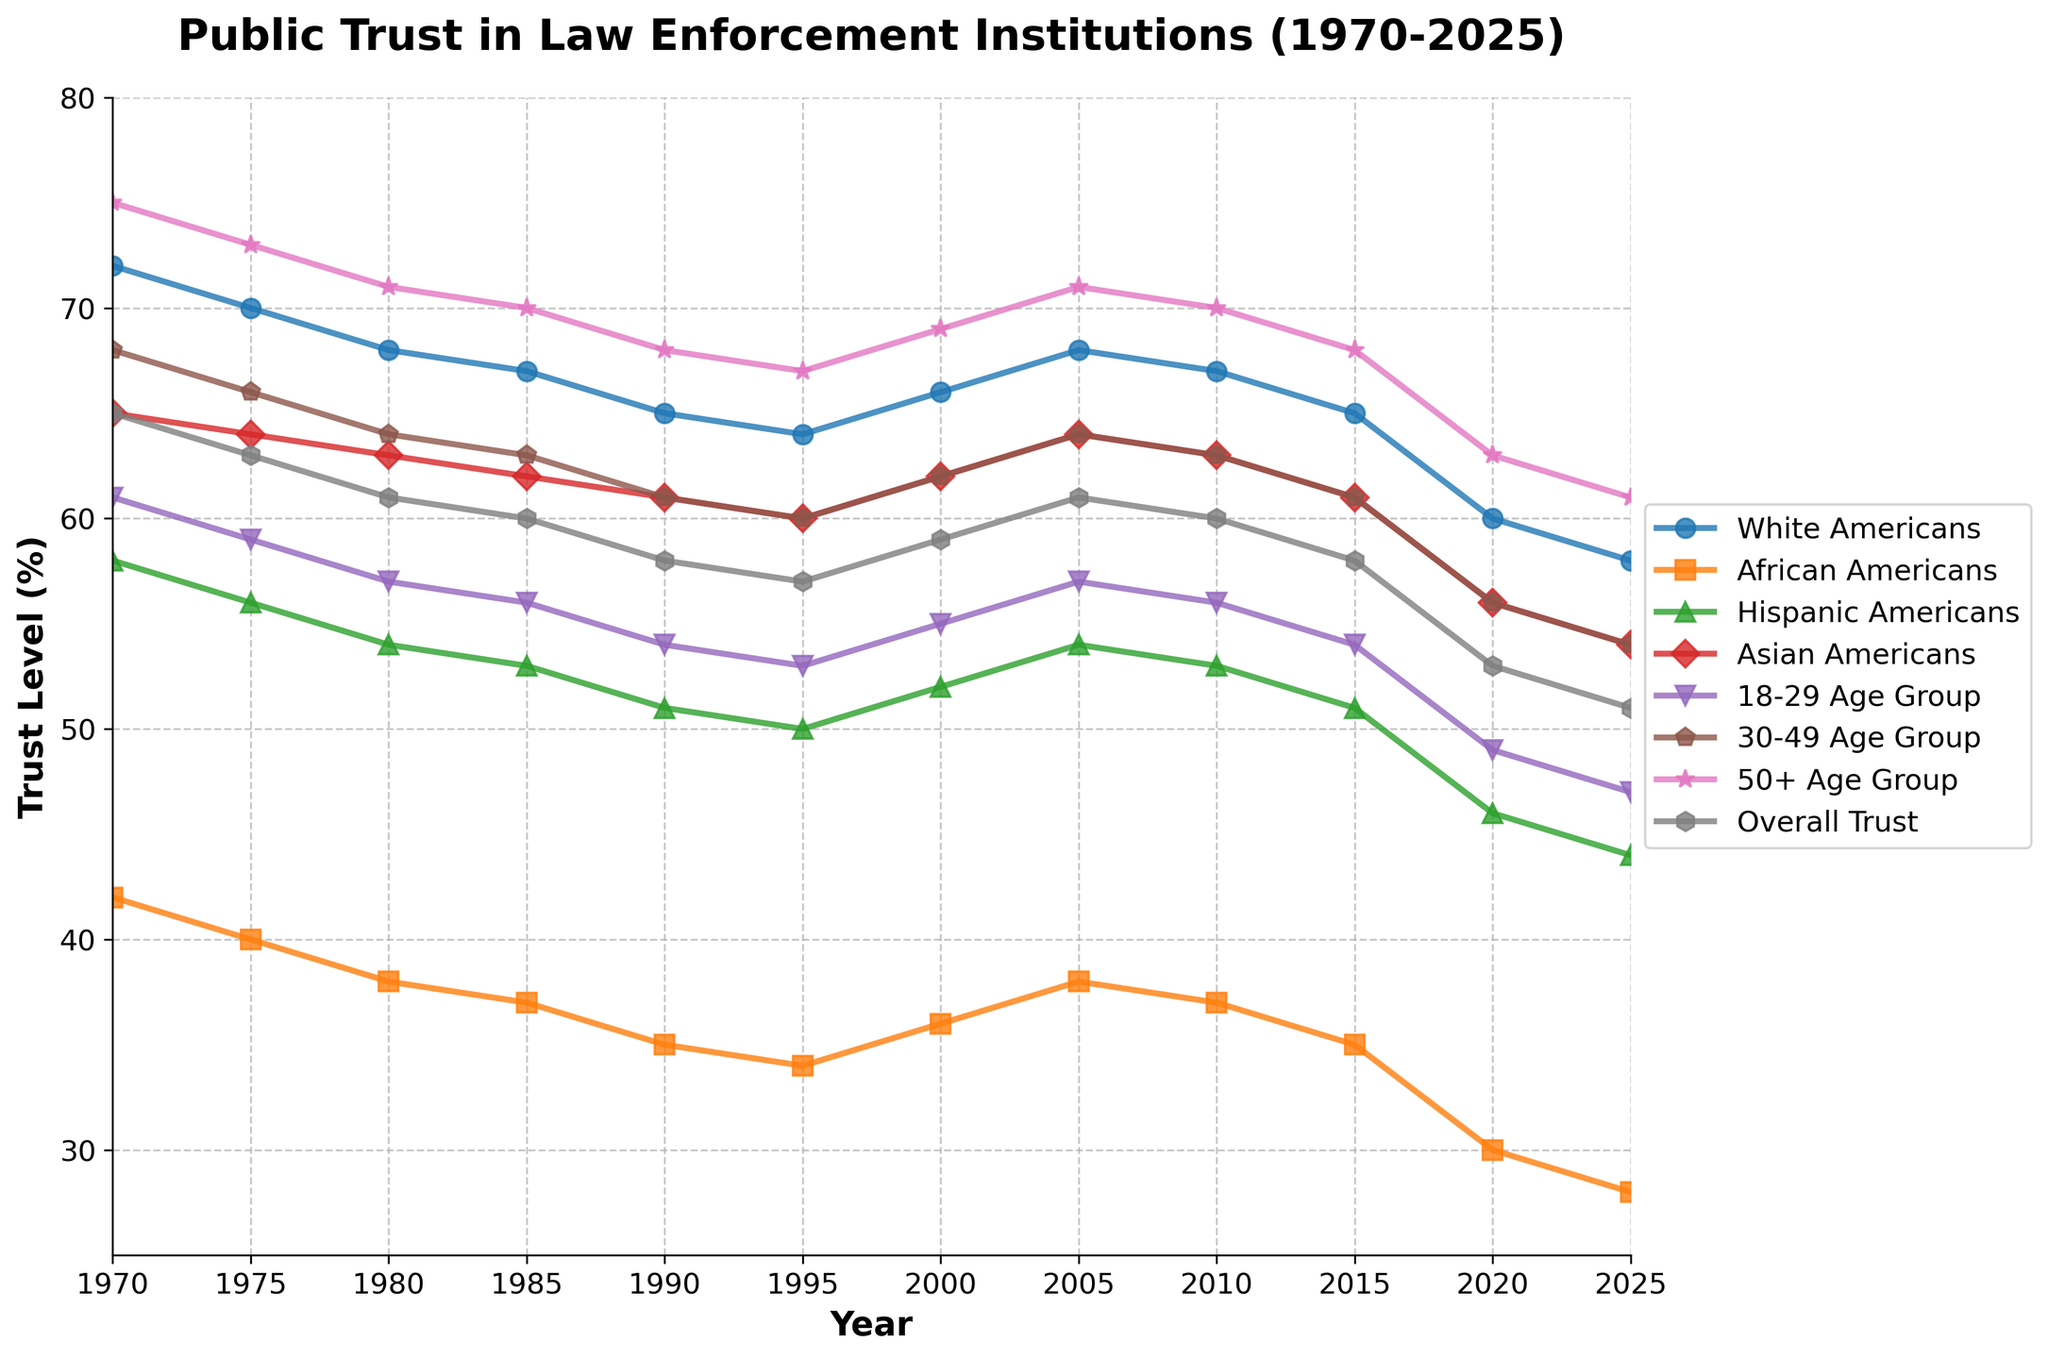What is the overall trend in public trust in law enforcement institutions from 1970 to 2025 for the 'Overall Trust' category? To determine the overall trend, look at the 'Overall Trust' line from 1970 to 2025. The trust level started at 65% in 1970 and gradually declined to 51% in 2025. Hence, the trend shows a decline in trust over time.
Answer: Overall trust has declined In which year did African Americans' trust in law enforcement drop below 30% for the first time? Trace the 'African Americans' line and identify the point where it first falls below 30%. In the figure, African Americans' trust level drops below 30% in the year 2020.
Answer: 2020 In 2025, which age group has the highest level of trust in law enforcement institutions? Examine the points for the year 2025 and compare the trust levels across the '18-29 Age Group', '30-49 Age Group', and '50+ Age Group'. The '50+ Age Group' has a trust level of 61%, which is higher than the other groups.
Answer: 50+ Age Group How does the trust level of Hispanic Americans in 1990 compare to the trust level of White Americans in the same year? Compare the two respective points in 1990. Hispanic Americans have a trust level of 51%, while White Americans have a trust level of 65%.
Answer: Lower by 14% What is the average trust level in law enforcement institutions for the 30-49 Age Group from 1970 to 2025? Calculate the average of the values for the '30-49 Age Group' from 1970 to 2025: (68+66+64+63+61+60+62+64+63+61+56+54)/12 = 62.08%
Answer: 62.08% Which demographic showed the most significant drop in trust from 2015 to 2025? Examine the changes in trust levels from 2015 to 2025 for all demographics. African Americans show the most significant drop in trust, declining from 35% to 28%, a 7% reduction.
Answer: African Americans What is the trust level difference between Asian Americans and the 18-29 Age Group in 1970? Refer to the values for 'Asian Americans' (65%) and '18-29 Age Group' (61%) in 1970. The difference is 65% - 61% = 4%.
Answer: 4% Which demographic had the least variation in trust levels from 1970 to 2025? Evaluate the range (difference between highest and lowest values) for each demographic line. White Americans had the smallest range with values changing from 72% to 58%, a difference of 14%.
Answer: White Americans By how much did the 'Overall Trust' change from 1980 to 2020? Compare the 'Overall Trust' values for 1980 (61%) and 2020 (53%). The change is 61% - 53% = 8%.
Answer: Decreased by 8% In which year did the 30-49 Age Group have the same level of trust in law enforcement as Hispanic Americans? Look for years where trust levels for the '30-49 Age Group' and 'Hispanic Americans' are equal. In the data, both groups had a trust level of 54% in 2025.
Answer: 2025 